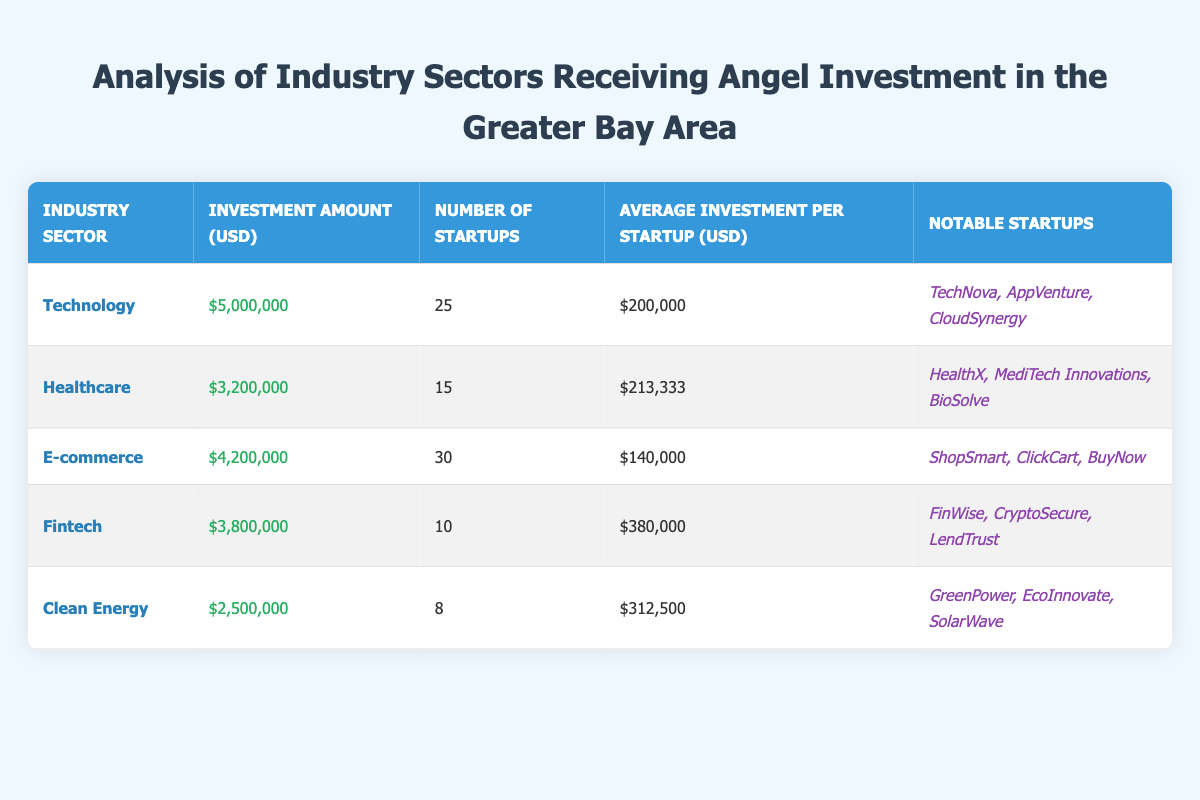What is the total investment amount in the Technology sector? The table indicates that the investment amount in the Technology sector is $5,000,000.
Answer: 5,000,000 How many startups received angel investment in the Healthcare sector? The table shows that 15 startups received angel investment in the Healthcare sector.
Answer: 15 What is the industry sector with the highest average investment per startup? By comparing the average investment amounts: Technology ($200,000), Healthcare ($213,333), E-commerce ($140,000), Fintech ($380,000), and Clean Energy ($312,500), it is clear that Fintech has the highest average investment per startup at $380,000.
Answer: Fintech Is the number of startups in the E-commerce sector greater than in the Clean Energy sector? The table shows that the E-commerce sector has 30 startups, while the Clean Energy sector has 8 startups. Since 30 is greater than 8, the statement is true.
Answer: Yes What is the total amount of investment across all sectors listed in the table? To find the total investment amount, I sum the investments: 5,000,000 (Technology) + 3,200,000 (Healthcare) + 4,200,000 (E-commerce) + 3,800,000 (Fintech) + 2,500,000 (Clean Energy) = 18,700,000.
Answer: 18,700,000 Which industry sector received the least amount of angel investment? By reviewing the investment amounts, Technology received $5,000,000, Healthcare $3,200,000, E-commerce $4,200,000, Fintech $3,800,000, and Clean Energy $2,500,000. The least investment is in the Clean Energy sector, with $2,500,000.
Answer: Clean Energy What is the difference in the number of startups between the Technology and Fintech sectors? The Technology sector has 25 startups, and the Fintech sector has 10 startups. The difference is calculated as 25 - 10 = 15.
Answer: 15 Are there more notable startups listed in the Technology sector than in the Clean Energy sector? The table indicates that Technology has 3 notable startups (TechNova, AppVenture, CloudSynergy) and Clean Energy also has 3 notable startups (GreenPower, EcoInnovate, SolarWave). Therefore, they have the same number of notable startups, so the answer is false.
Answer: No What is the average investment per startup in the E-commerce sector? The table shows that the investment amount in the E-commerce sector is $4,200,000, and it has 30 startups. The average per startup is 4,200,000 divided by 30, which equals $140,000.
Answer: 140,000 